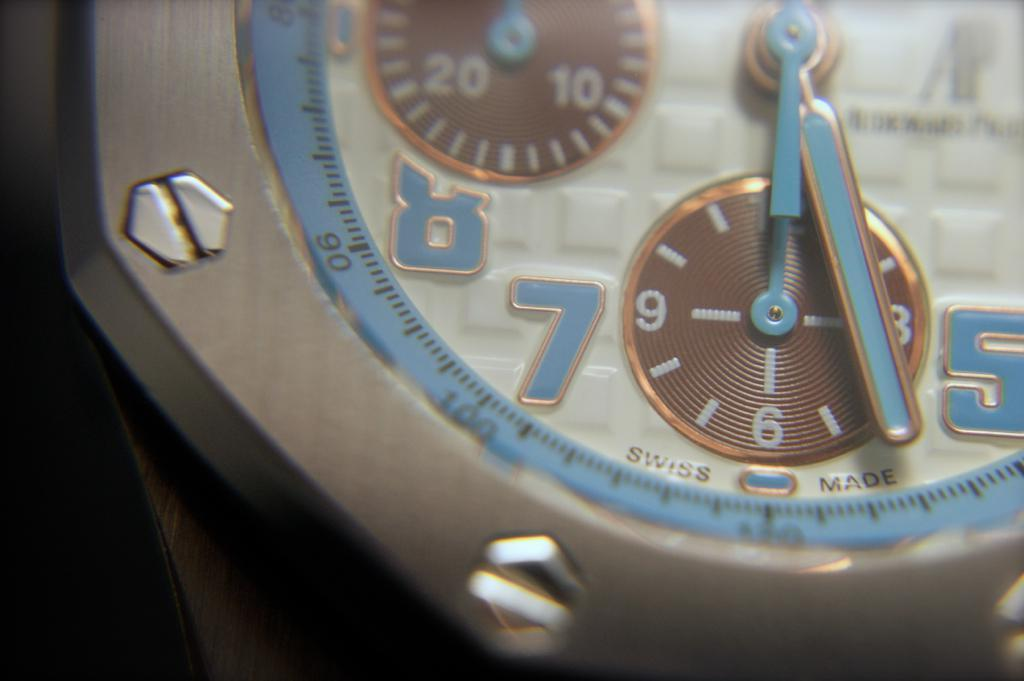<image>
Describe the image concisely. A Swiss made watch has light blue hands and matching numbers. 